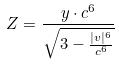<formula> <loc_0><loc_0><loc_500><loc_500>Z = \frac { y \cdot c ^ { 6 } } { \sqrt { 3 - \frac { | v | ^ { 6 } } { c ^ { 6 } } } }</formula> 